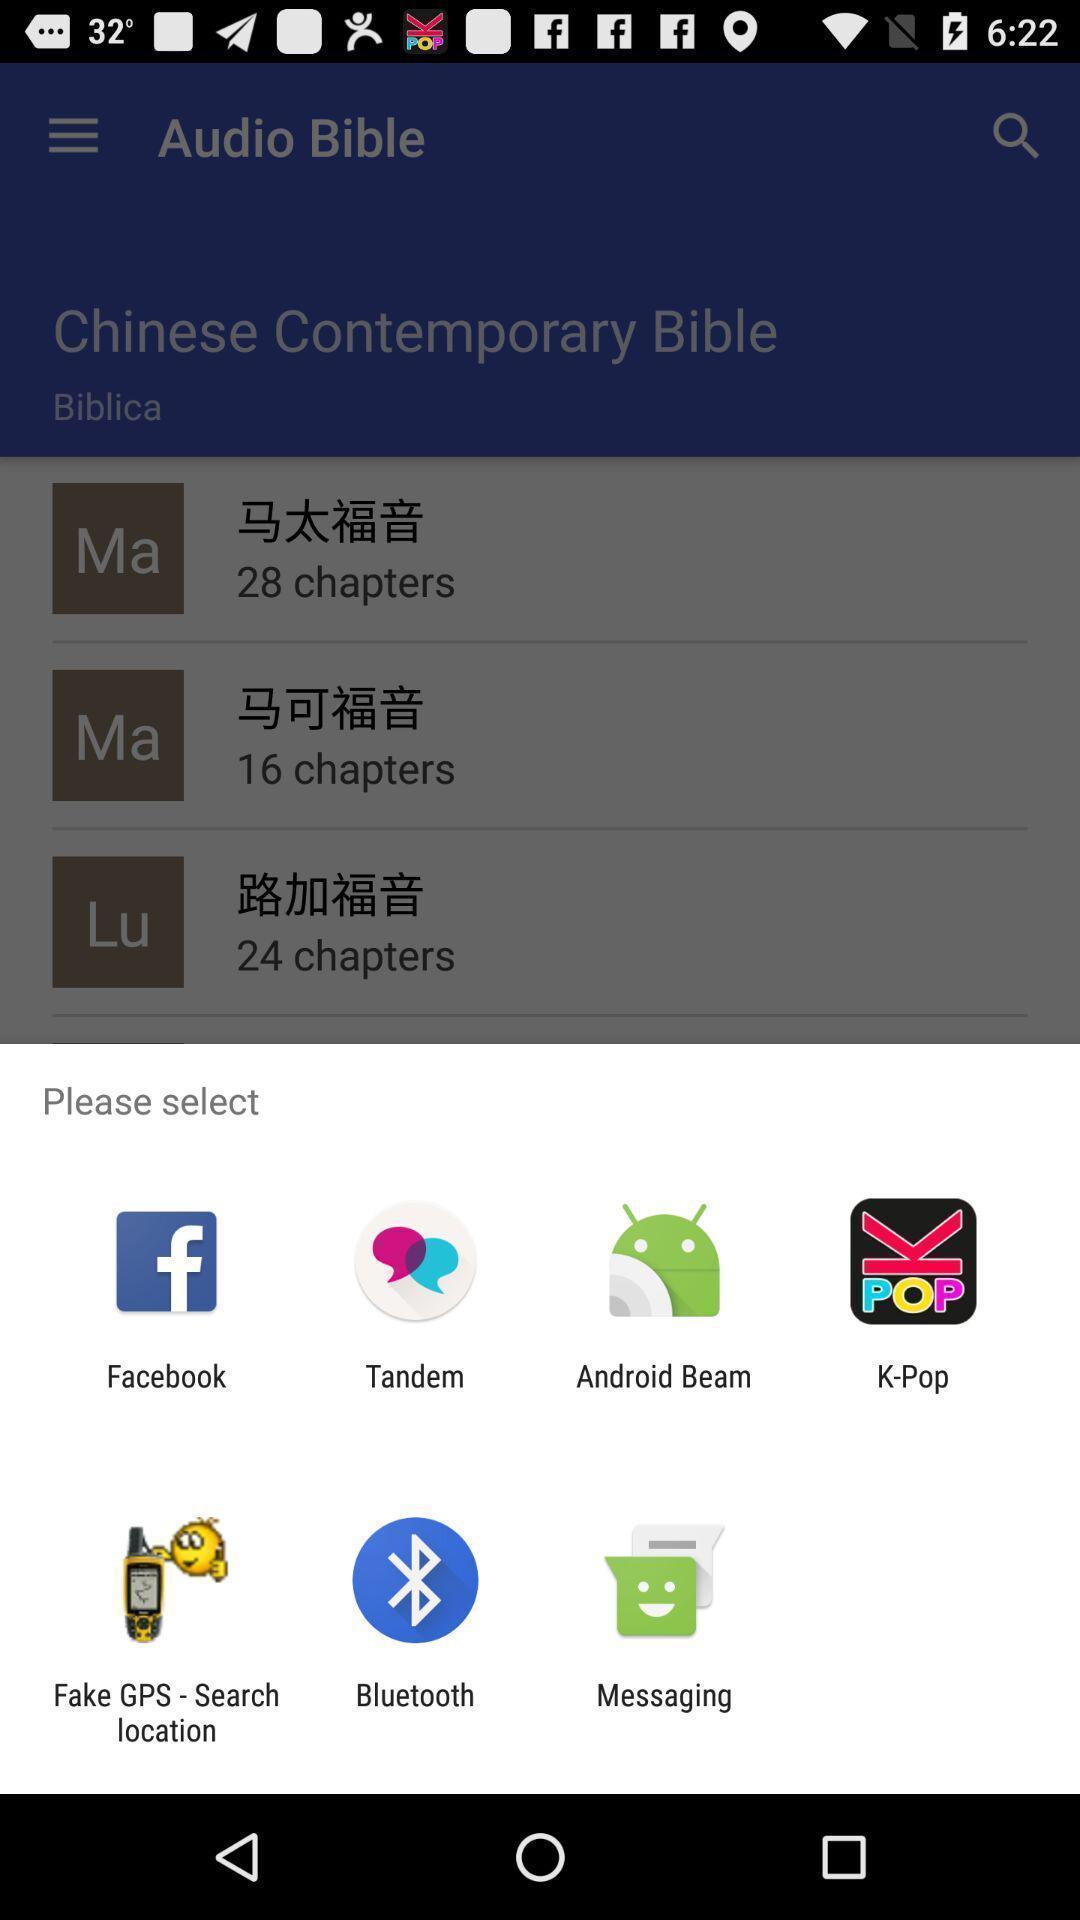Tell me about the visual elements in this screen capture. Push up message with multiple sharing options. 